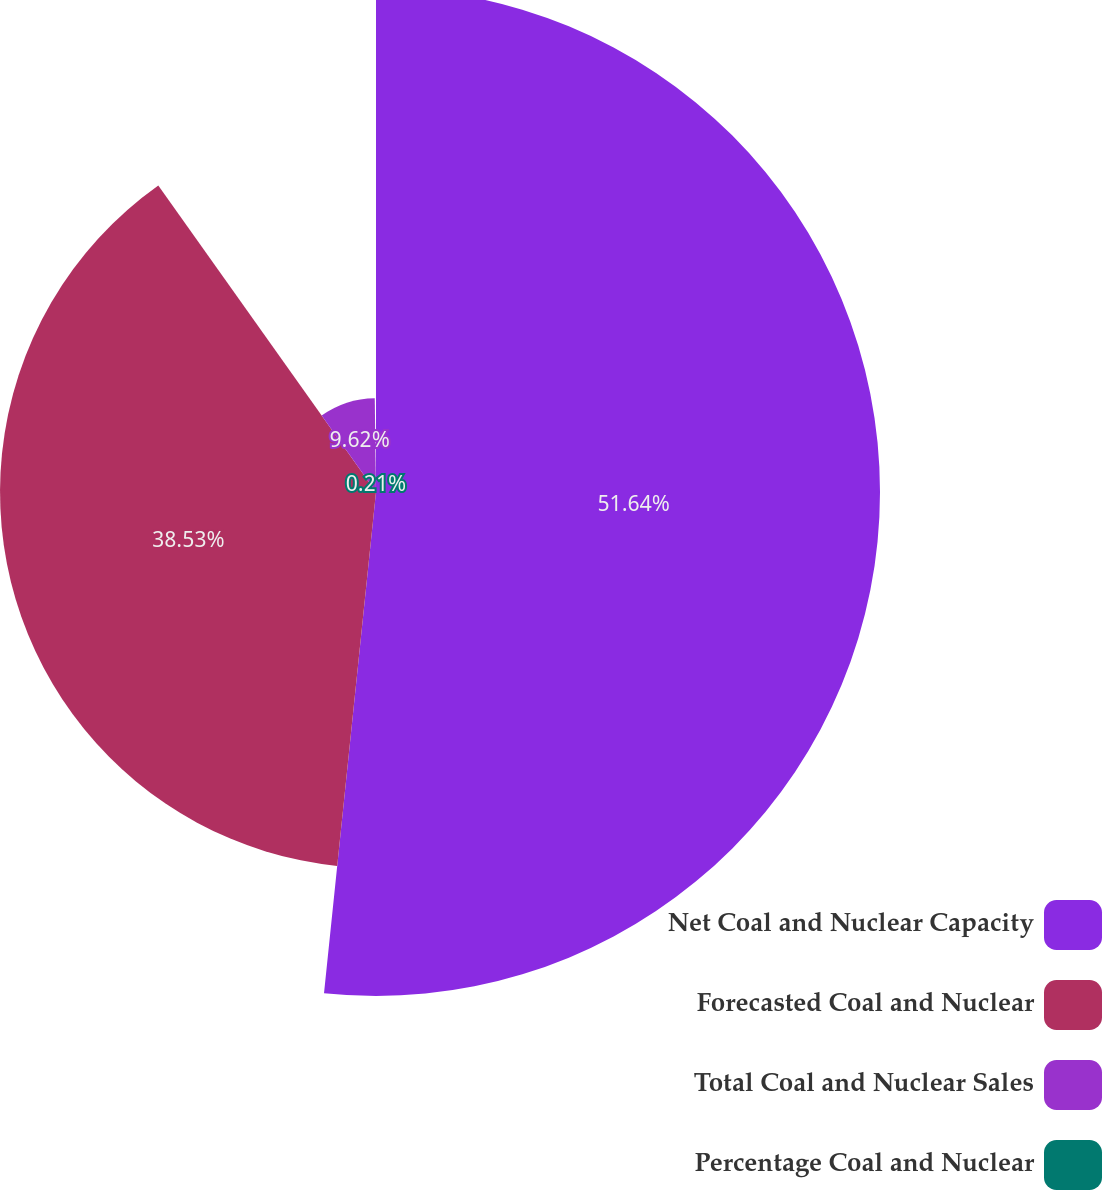Convert chart to OTSL. <chart><loc_0><loc_0><loc_500><loc_500><pie_chart><fcel>Net Coal and Nuclear Capacity<fcel>Forecasted Coal and Nuclear<fcel>Total Coal and Nuclear Sales<fcel>Percentage Coal and Nuclear<nl><fcel>51.65%<fcel>38.53%<fcel>9.62%<fcel>0.21%<nl></chart> 